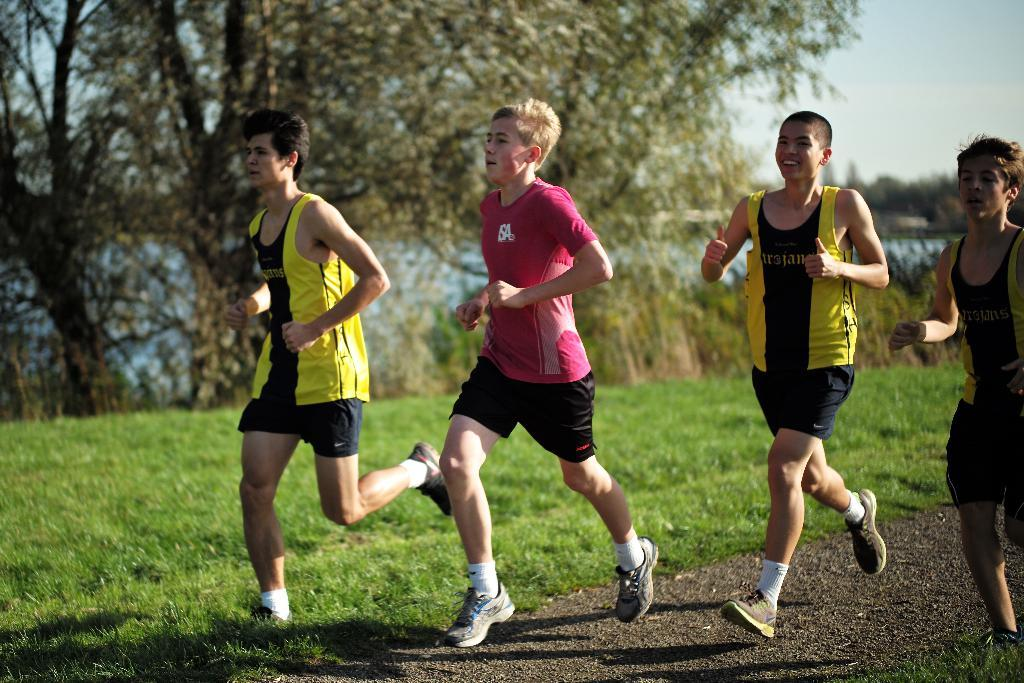What are the people in the image doing? The people in the image are running. On what surface are the people running? The people are running on a road. What type of vegetation is present around the road? There is grass around the road. What can be seen in the background of the image? There are trees in the background of the image. Can you see any cobwebs on the trees in the image? There is no mention of cobwebs in the image, so we cannot determine if they are present or not. 